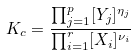<formula> <loc_0><loc_0><loc_500><loc_500>K _ { c } = \frac { \prod _ { j = 1 } ^ { p } [ Y _ { j } ] ^ { \eta _ { j } } } { \prod _ { i = 1 } ^ { r } [ X _ { i } ] ^ { \nu _ { i } } }</formula> 